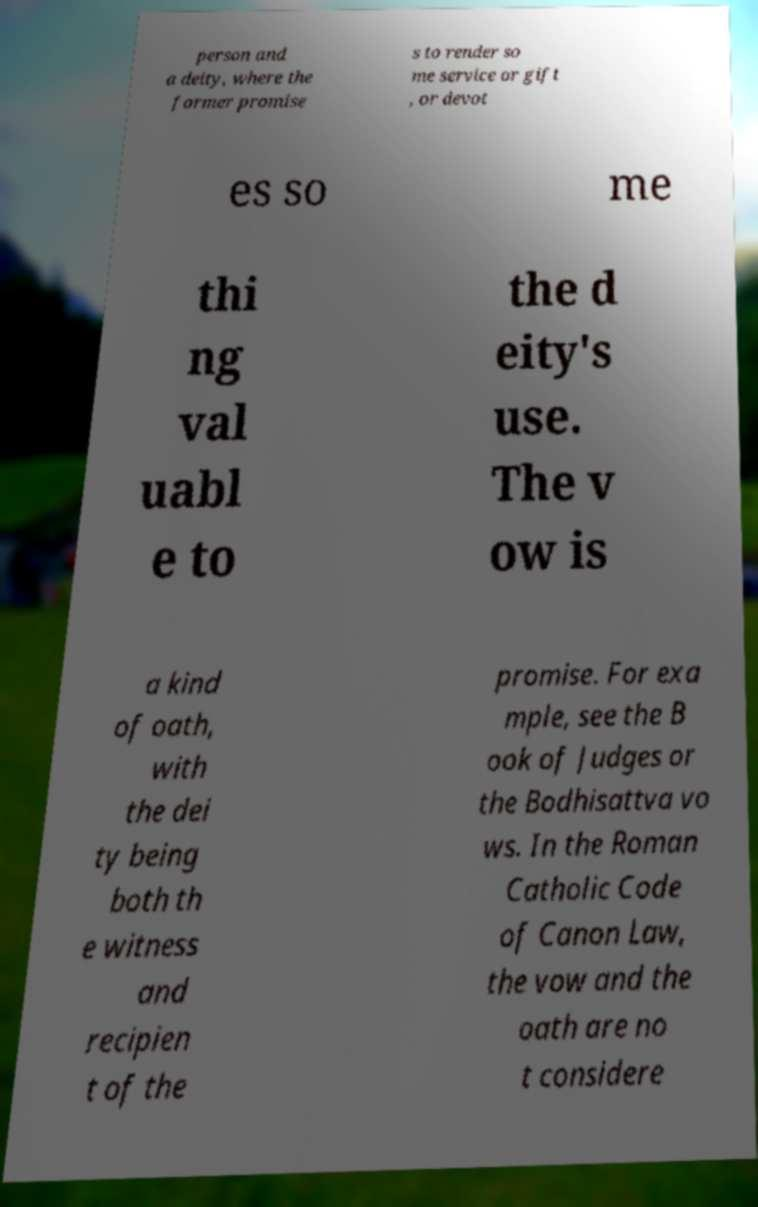Please read and relay the text visible in this image. What does it say? person and a deity, where the former promise s to render so me service or gift , or devot es so me thi ng val uabl e to the d eity's use. The v ow is a kind of oath, with the dei ty being both th e witness and recipien t of the promise. For exa mple, see the B ook of Judges or the Bodhisattva vo ws. In the Roman Catholic Code of Canon Law, the vow and the oath are no t considere 